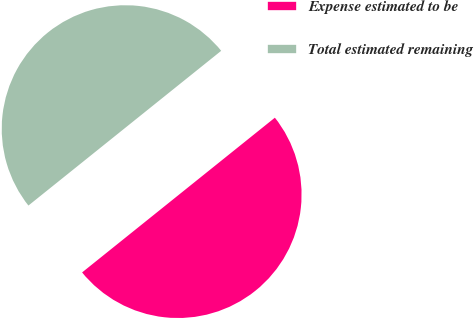Convert chart. <chart><loc_0><loc_0><loc_500><loc_500><pie_chart><fcel>Expense estimated to be<fcel>Total estimated remaining<nl><fcel>50.0%<fcel>50.0%<nl></chart> 